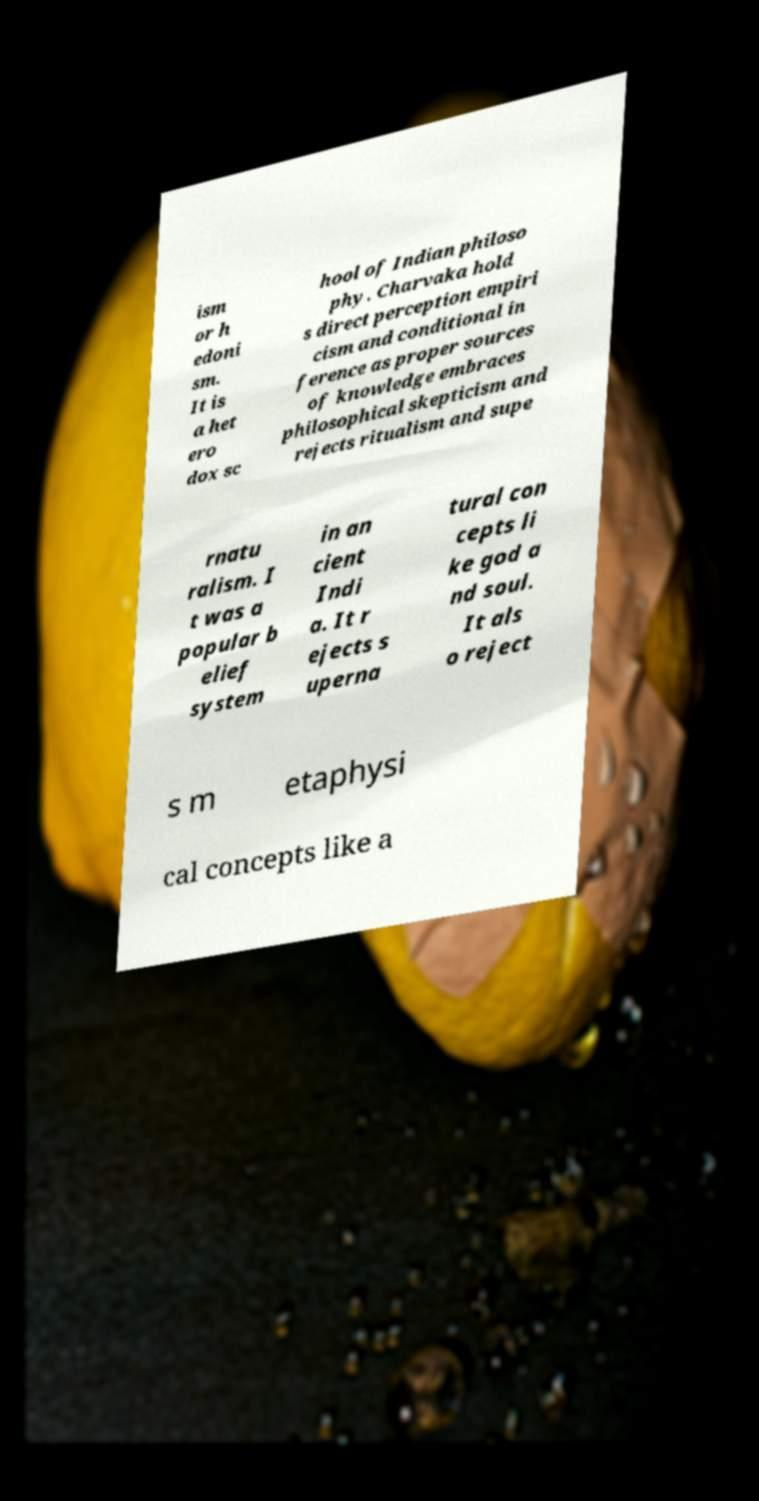Could you assist in decoding the text presented in this image and type it out clearly? ism or h edoni sm. It is a het ero dox sc hool of Indian philoso phy. Charvaka hold s direct perception empiri cism and conditional in ference as proper sources of knowledge embraces philosophical skepticism and rejects ritualism and supe rnatu ralism. I t was a popular b elief system in an cient Indi a. It r ejects s uperna tural con cepts li ke god a nd soul. It als o reject s m etaphysi cal concepts like a 